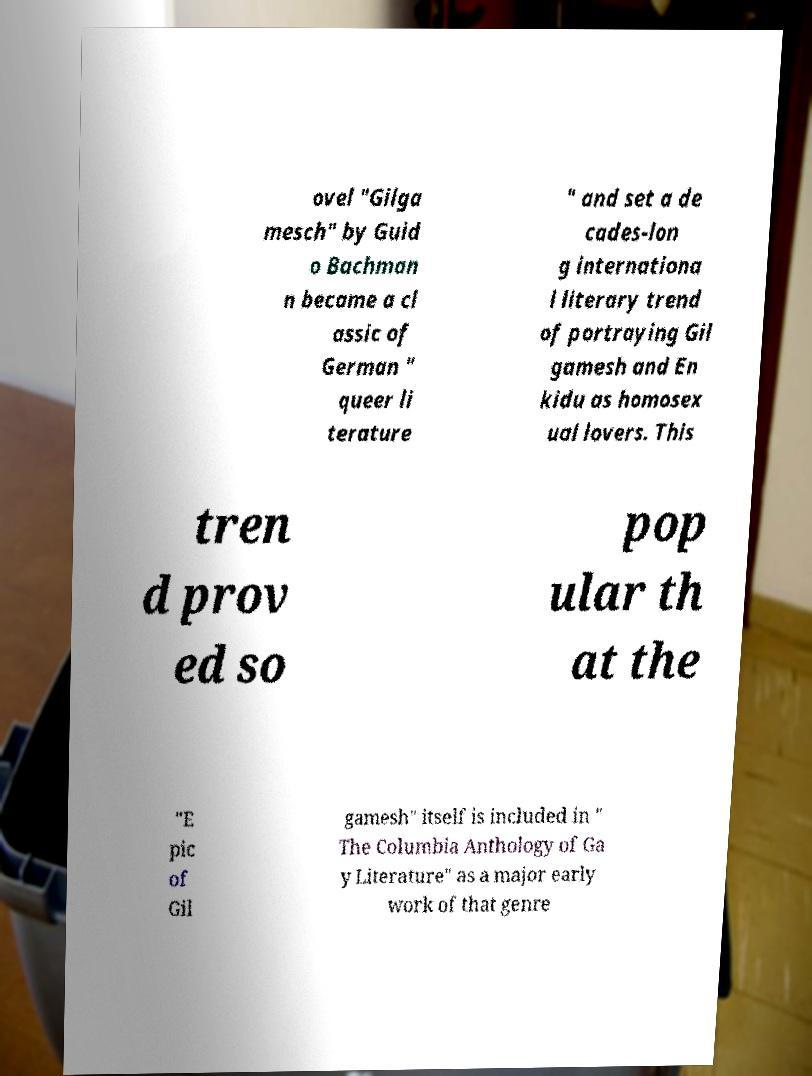Could you extract and type out the text from this image? ovel "Gilga mesch" by Guid o Bachman n became a cl assic of German " queer li terature " and set a de cades-lon g internationa l literary trend of portraying Gil gamesh and En kidu as homosex ual lovers. This tren d prov ed so pop ular th at the "E pic of Gil gamesh" itself is included in " The Columbia Anthology of Ga y Literature" as a major early work of that genre 